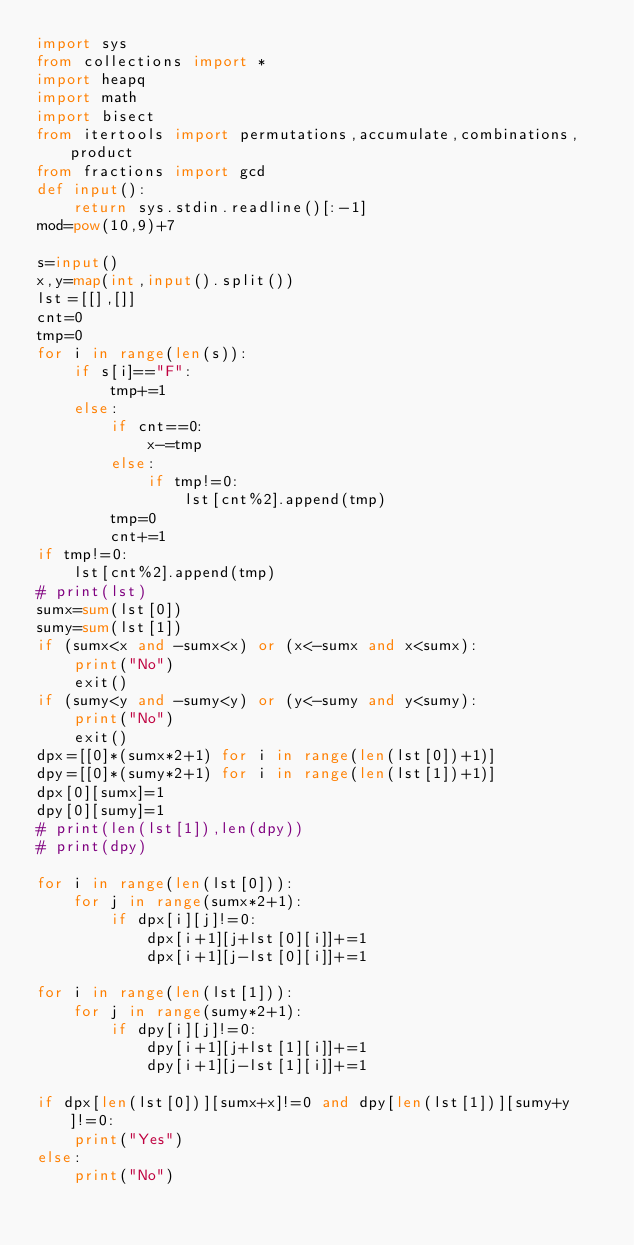Convert code to text. <code><loc_0><loc_0><loc_500><loc_500><_Python_>import sys
from collections import *
import heapq
import math
import bisect
from itertools import permutations,accumulate,combinations,product
from fractions import gcd
def input():
    return sys.stdin.readline()[:-1]
mod=pow(10,9)+7

s=input()
x,y=map(int,input().split())
lst=[[],[]]
cnt=0
tmp=0
for i in range(len(s)):
    if s[i]=="F":
        tmp+=1
    else:
        if cnt==0:
            x-=tmp
        else:
            if tmp!=0:
                lst[cnt%2].append(tmp)
        tmp=0
        cnt+=1
if tmp!=0:
    lst[cnt%2].append(tmp)
# print(lst)
sumx=sum(lst[0])
sumy=sum(lst[1])
if (sumx<x and -sumx<x) or (x<-sumx and x<sumx):
    print("No")
    exit()
if (sumy<y and -sumy<y) or (y<-sumy and y<sumy):
    print("No")
    exit()
dpx=[[0]*(sumx*2+1) for i in range(len(lst[0])+1)]
dpy=[[0]*(sumy*2+1) for i in range(len(lst[1])+1)]
dpx[0][sumx]=1
dpy[0][sumy]=1
# print(len(lst[1]),len(dpy))
# print(dpy)

for i in range(len(lst[0])):
    for j in range(sumx*2+1):
        if dpx[i][j]!=0:
            dpx[i+1][j+lst[0][i]]+=1
            dpx[i+1][j-lst[0][i]]+=1

for i in range(len(lst[1])):
    for j in range(sumy*2+1):
        if dpy[i][j]!=0:
            dpy[i+1][j+lst[1][i]]+=1
            dpy[i+1][j-lst[1][i]]+=1

if dpx[len(lst[0])][sumx+x]!=0 and dpy[len(lst[1])][sumy+y]!=0:
    print("Yes")
else:
    print("No")</code> 